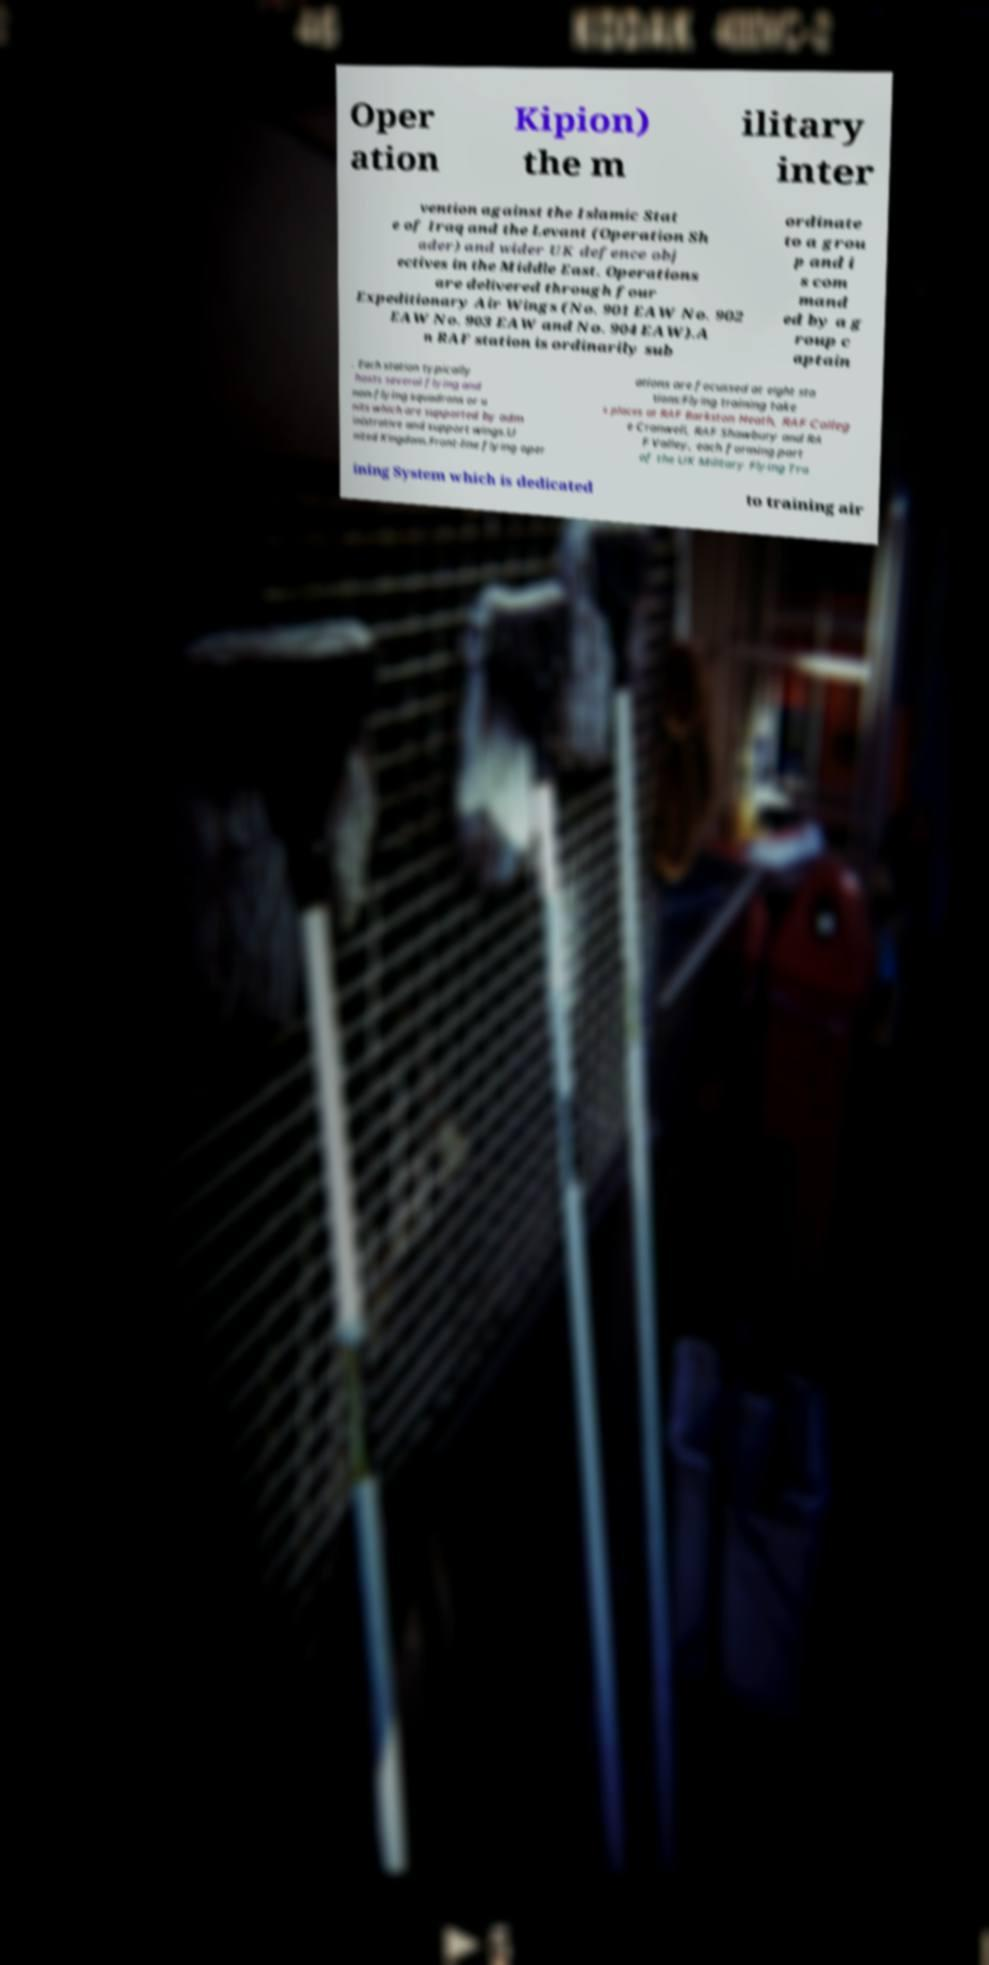There's text embedded in this image that I need extracted. Can you transcribe it verbatim? Oper ation Kipion) the m ilitary inter vention against the Islamic Stat e of Iraq and the Levant (Operation Sh ader) and wider UK defence obj ectives in the Middle East. Operations are delivered through four Expeditionary Air Wings (No. 901 EAW No. 902 EAW No. 903 EAW and No. 904 EAW).A n RAF station is ordinarily sub ordinate to a grou p and i s com mand ed by a g roup c aptain . Each station typically hosts several flying and non-flying squadrons or u nits which are supported by adm inistrative and support wings.U nited Kingdom.Front-line flying oper ations are focussed at eight sta tions:Flying training take s places at RAF Barkston Heath, RAF Colleg e Cranwell, RAF Shawbury and RA F Valley, each forming part of the UK Military Flying Tra ining System which is dedicated to training air 